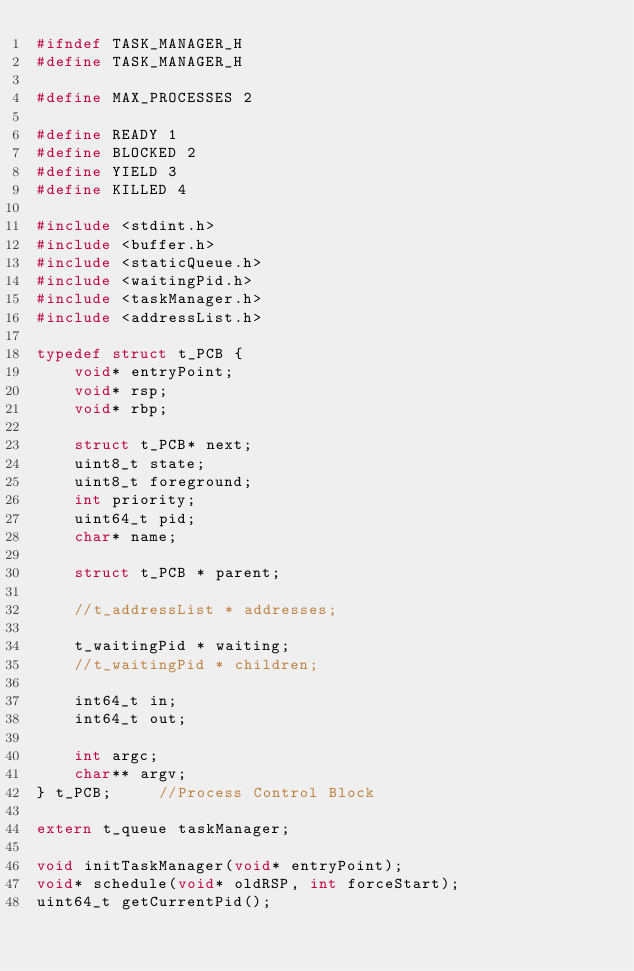<code> <loc_0><loc_0><loc_500><loc_500><_C_>#ifndef TASK_MANAGER_H
#define TASK_MANAGER_H

#define MAX_PROCESSES 2

#define READY 1
#define BLOCKED 2
#define YIELD 3
#define KILLED 4

#include <stdint.h>
#include <buffer.h>
#include <staticQueue.h>
#include <waitingPid.h>
#include <taskManager.h>
#include <addressList.h>

typedef struct t_PCB {
    void* entryPoint;
    void* rsp;
    void* rbp;

    struct t_PCB* next;
    uint8_t state;
    uint8_t foreground;
    int priority;
    uint64_t pid;
    char* name;

    struct t_PCB * parent;

    //t_addressList * addresses;

    t_waitingPid * waiting;
    //t_waitingPid * children;

    int64_t in;
    int64_t out;

    int argc;
    char** argv;
} t_PCB;     //Process Control Block

extern t_queue taskManager;

void initTaskManager(void* entryPoint);
void* schedule(void* oldRSP, int forceStart);
uint64_t getCurrentPid();</code> 